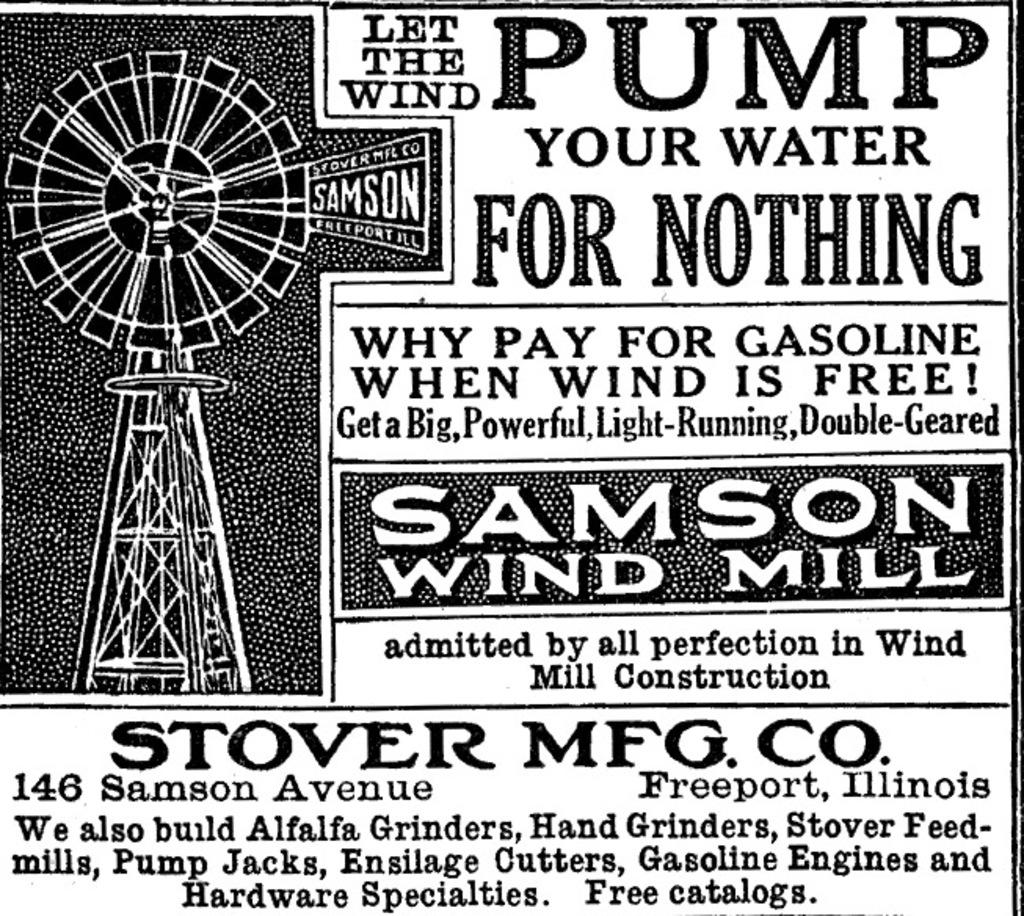Provide a one-sentence caption for the provided image. a very old fashion newspaper advertisement for pumping water. 